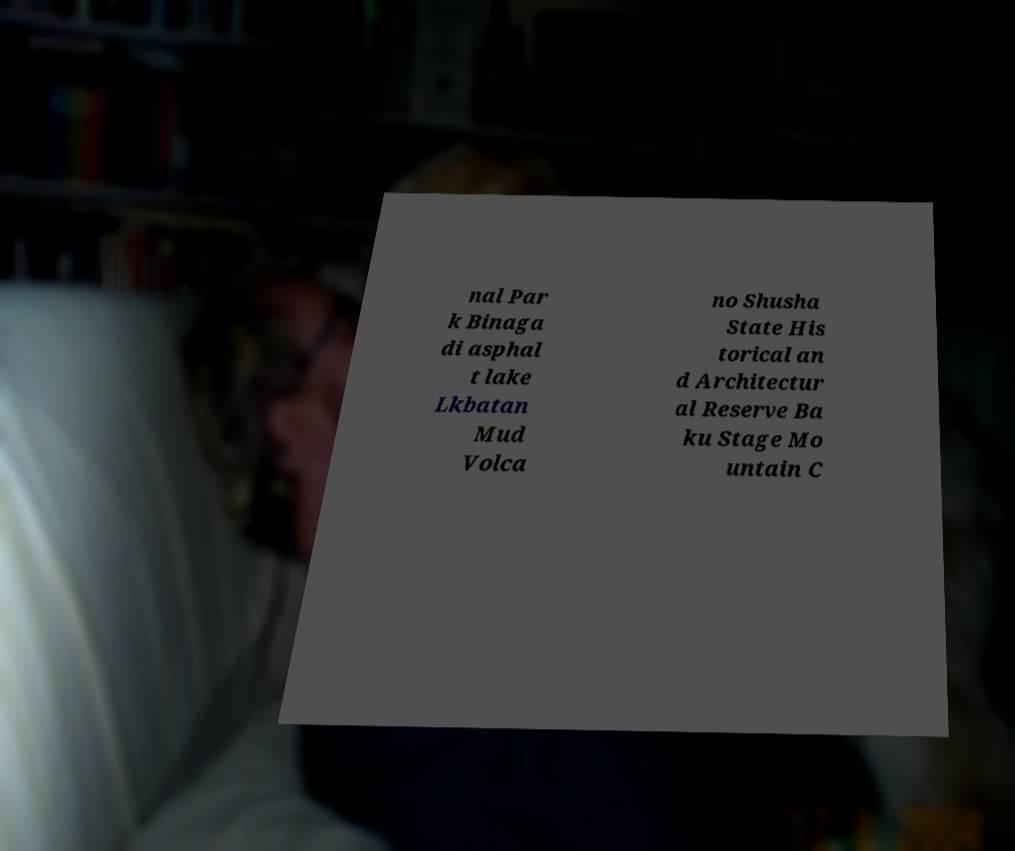Can you read and provide the text displayed in the image?This photo seems to have some interesting text. Can you extract and type it out for me? nal Par k Binaga di asphal t lake Lkbatan Mud Volca no Shusha State His torical an d Architectur al Reserve Ba ku Stage Mo untain C 